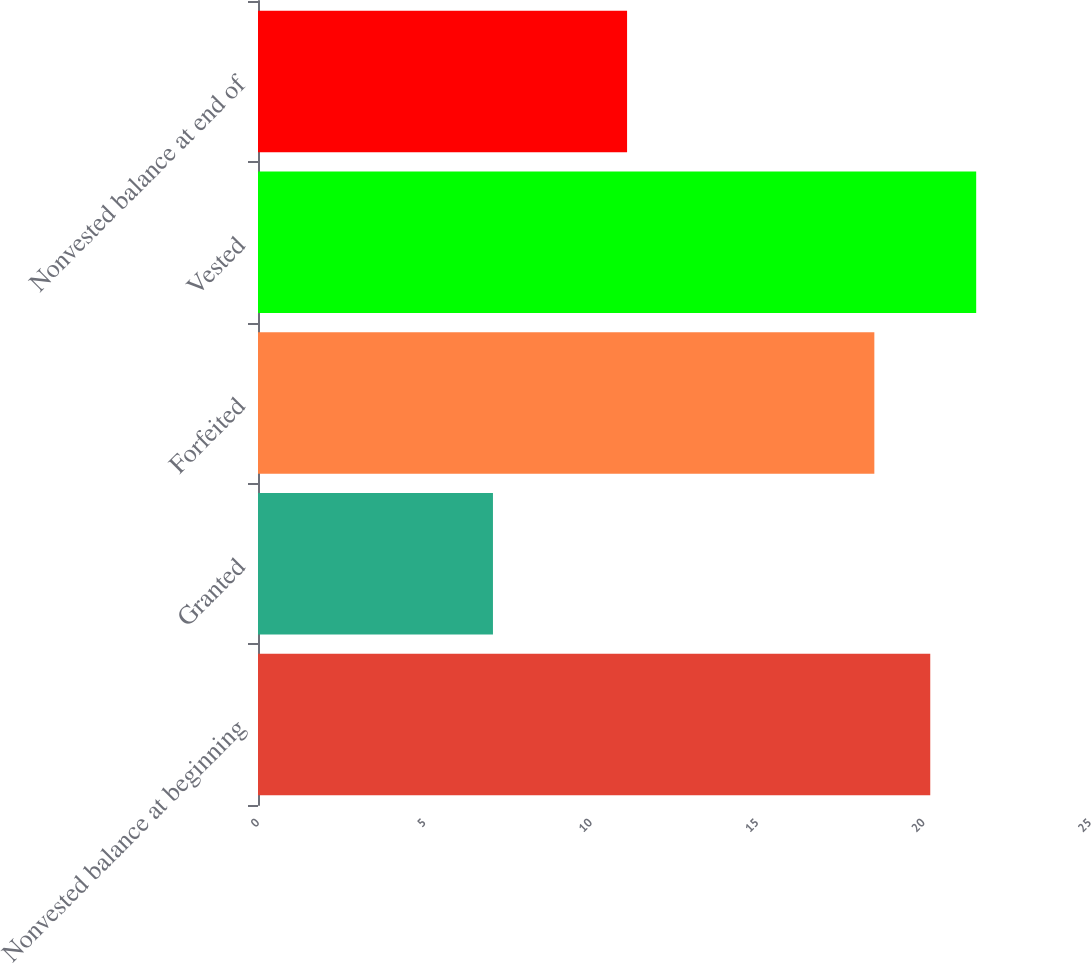Convert chart to OTSL. <chart><loc_0><loc_0><loc_500><loc_500><bar_chart><fcel>Nonvested balance at beginning<fcel>Granted<fcel>Forfeited<fcel>Vested<fcel>Nonvested balance at end of<nl><fcel>20.2<fcel>7.06<fcel>18.52<fcel>21.58<fcel>11.09<nl></chart> 